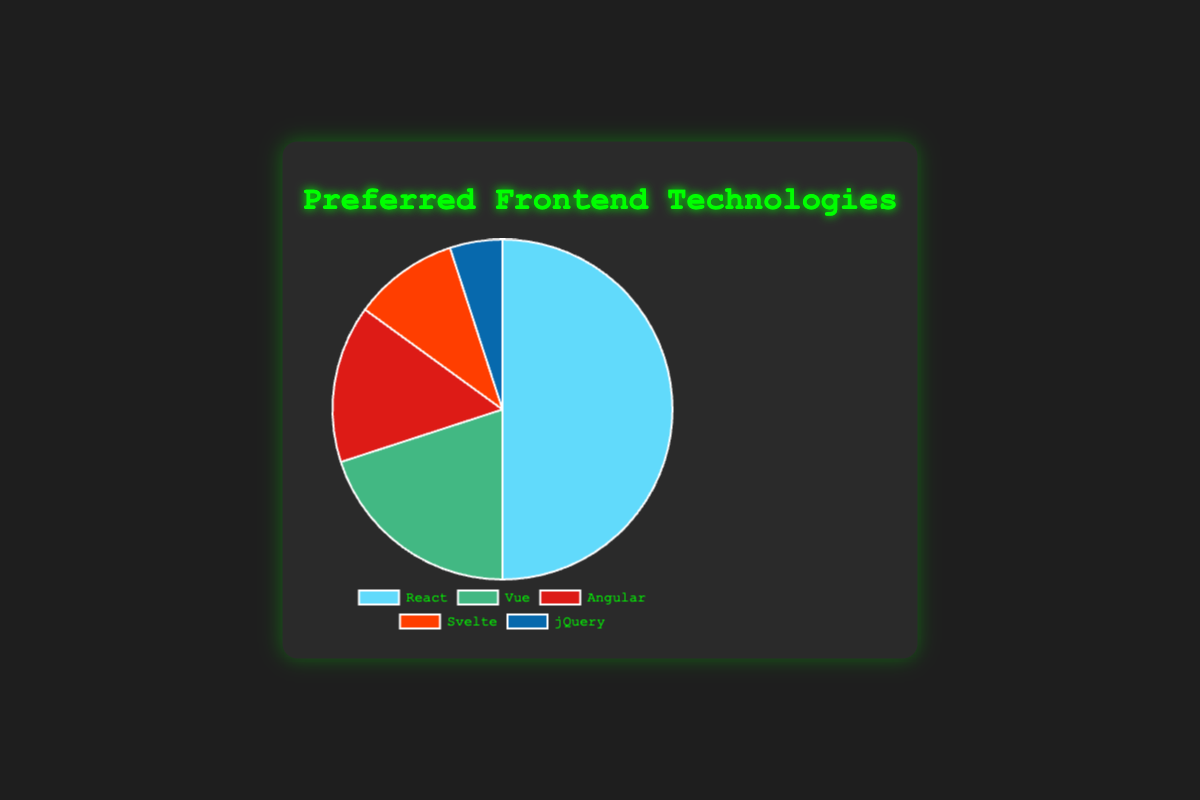What technology has the largest share in the pie chart? The largest portion of the pie chart is given to React. This is visually noticeable as React's segment occupies half of the chart (50%).
Answer: React What is the combined percentage of Vue and Angular? Vue has 20% and Angular has 15%, so their combined percentage is 20% + 15% = 35%.
Answer: 35% How many times larger is the portion for React compared to jQuery? React has 50% and jQuery has 5%. To find how many times larger React's portion is, divide 50% by 5%, which yields 50 / 5 = 10.
Answer: 10 What is the total percentage of technologies other than React? The total percentage is the sum of Vue, Angular, Svelte, and jQuery: 20% + 15% + 10% + 5% = 50%.
Answer: 50% Which technology has the smallest share in the pie chart? The smallest portion of the pie chart is allocated to jQuery, which has 5%.
Answer: jQuery Is the share of Vue greater than the combined share of Svelte and jQuery? Vue has 20% while Svelte and jQuery together have 10% + 5% = 15%. 20% is greater than 15%.
Answer: Yes By how much does React's share exceed Angular's share? React has 50% and Angular has 15%. The difference is 50% - 15% = 35%.
Answer: 35% What is the most frequent color among the pie chart segments? React's segment is blue, and it occupies the largest visual area in the chart.
Answer: Blue Which technology's share is exactly half of Vue's share? Vue has 20%. Half of 20% is 10%, which corresponds to Svelte's share.
Answer: Svelte Is the share of Svelte plus Angular greater than or equal to the share of React? Svelte has 10% and Angular has 15%, their sum is 10% + 15% = 25%. React has 50%, which is greater than 25%.
Answer: No 